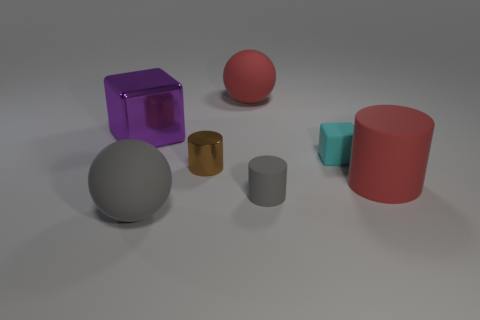Subtract all small brown cylinders. How many cylinders are left? 2 Add 2 large blue matte cubes. How many objects exist? 9 Subtract all balls. How many objects are left? 5 Subtract 1 brown cylinders. How many objects are left? 6 Subtract all blue cylinders. Subtract all brown cubes. How many cylinders are left? 3 Subtract all small yellow shiny cylinders. Subtract all metallic cylinders. How many objects are left? 6 Add 1 rubber balls. How many rubber balls are left? 3 Add 7 purple metallic things. How many purple metallic things exist? 8 